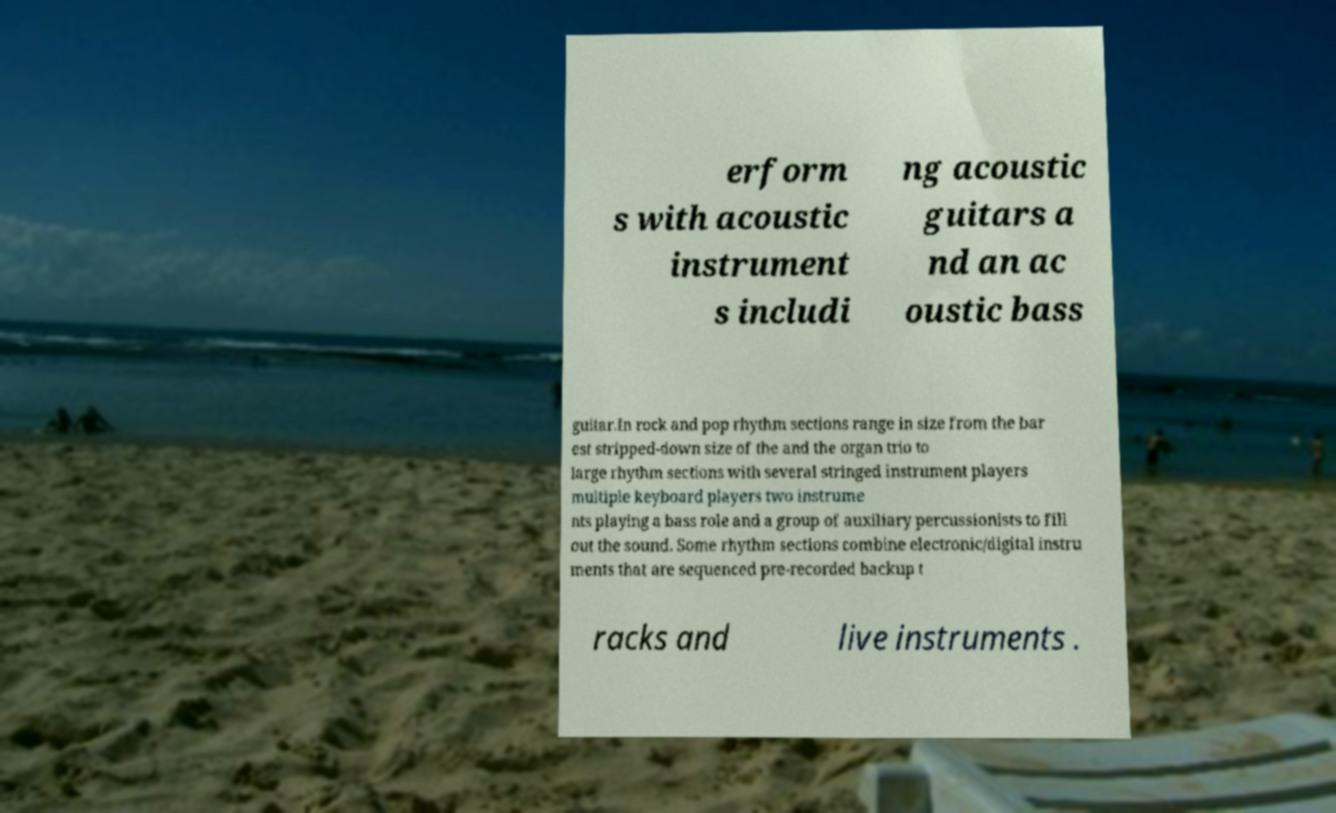I need the written content from this picture converted into text. Can you do that? erform s with acoustic instrument s includi ng acoustic guitars a nd an ac oustic bass guitar.In rock and pop rhythm sections range in size from the bar est stripped-down size of the and the organ trio to large rhythm sections with several stringed instrument players multiple keyboard players two instrume nts playing a bass role and a group of auxiliary percussionists to fill out the sound. Some rhythm sections combine electronic/digital instru ments that are sequenced pre-recorded backup t racks and live instruments . 